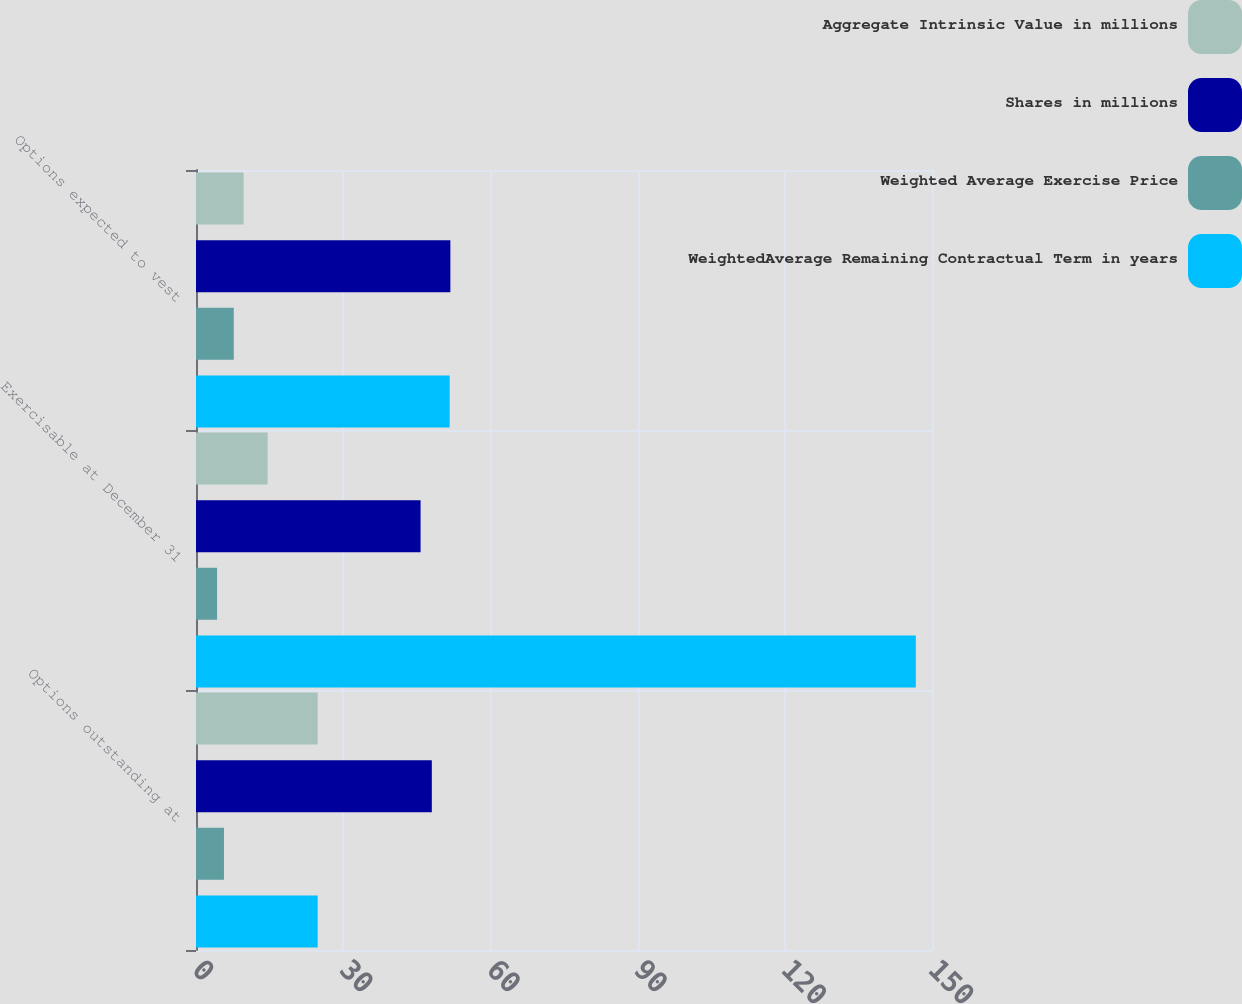Convert chart to OTSL. <chart><loc_0><loc_0><loc_500><loc_500><stacked_bar_chart><ecel><fcel>Options outstanding at<fcel>Exercisable at December 31<fcel>Options expected to vest<nl><fcel>Aggregate Intrinsic Value in millions<fcel>24.8<fcel>14.6<fcel>9.7<nl><fcel>Shares in millions<fcel>48.06<fcel>45.77<fcel>51.84<nl><fcel>Weighted Average Exercise Price<fcel>5.7<fcel>4.3<fcel>7.7<nl><fcel>WeightedAverage Remaining Contractual Term in years<fcel>24.8<fcel>146.7<fcel>51.7<nl></chart> 